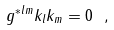<formula> <loc_0><loc_0><loc_500><loc_500>g ^ { * l m } k _ { l } k _ { m } = 0 \ ,</formula> 